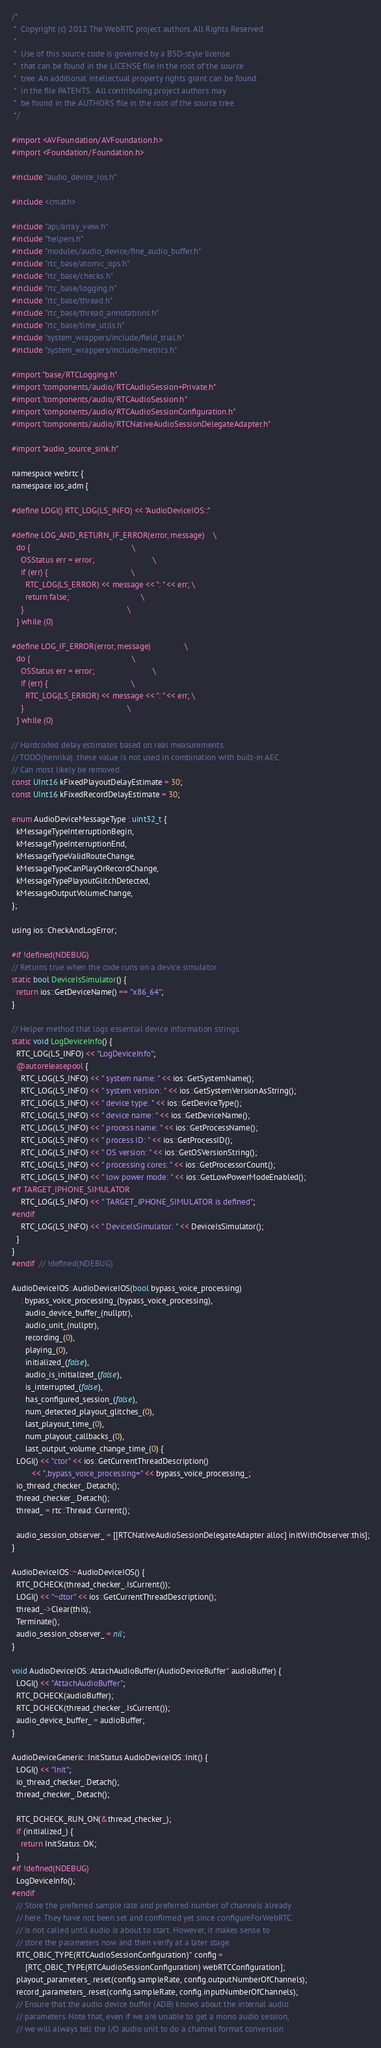Convert code to text. <code><loc_0><loc_0><loc_500><loc_500><_ObjectiveC_>/*
 *  Copyright (c) 2012 The WebRTC project authors. All Rights Reserved.
 *
 *  Use of this source code is governed by a BSD-style license
 *  that can be found in the LICENSE file in the root of the source
 *  tree. An additional intellectual property rights grant can be found
 *  in the file PATENTS.  All contributing project authors may
 *  be found in the AUTHORS file in the root of the source tree.
 */

#import <AVFoundation/AVFoundation.h>
#import <Foundation/Foundation.h>

#include "audio_device_ios.h"

#include <cmath>

#include "api/array_view.h"
#include "helpers.h"
#include "modules/audio_device/fine_audio_buffer.h"
#include "rtc_base/atomic_ops.h"
#include "rtc_base/checks.h"
#include "rtc_base/logging.h"
#include "rtc_base/thread.h"
#include "rtc_base/thread_annotations.h"
#include "rtc_base/time_utils.h"
#include "system_wrappers/include/field_trial.h"
#include "system_wrappers/include/metrics.h"

#import "base/RTCLogging.h"
#import "components/audio/RTCAudioSession+Private.h"
#import "components/audio/RTCAudioSession.h"
#import "components/audio/RTCAudioSessionConfiguration.h"
#import "components/audio/RTCNativeAudioSessionDelegateAdapter.h"

#import "audio_source_sink.h"

namespace webrtc {
namespace ios_adm {

#define LOGI() RTC_LOG(LS_INFO) << "AudioDeviceIOS::"

#define LOG_AND_RETURN_IF_ERROR(error, message)    \
  do {                                             \
    OSStatus err = error;                          \
    if (err) {                                     \
      RTC_LOG(LS_ERROR) << message << ": " << err; \
      return false;                                \
    }                                              \
  } while (0)

#define LOG_IF_ERROR(error, message)               \
  do {                                             \
    OSStatus err = error;                          \
    if (err) {                                     \
      RTC_LOG(LS_ERROR) << message << ": " << err; \
    }                                              \
  } while (0)

// Hardcoded delay estimates based on real measurements.
// TODO(henrika): these value is not used in combination with built-in AEC.
// Can most likely be removed.
const UInt16 kFixedPlayoutDelayEstimate = 30;
const UInt16 kFixedRecordDelayEstimate = 30;

enum AudioDeviceMessageType : uint32_t {
  kMessageTypeInterruptionBegin,
  kMessageTypeInterruptionEnd,
  kMessageTypeValidRouteChange,
  kMessageTypeCanPlayOrRecordChange,
  kMessageTypePlayoutGlitchDetected,
  kMessageOutputVolumeChange,
};

using ios::CheckAndLogError;

#if !defined(NDEBUG)
// Returns true when the code runs on a device simulator.
static bool DeviceIsSimulator() {
  return ios::GetDeviceName() == "x86_64";
}

// Helper method that logs essential device information strings.
static void LogDeviceInfo() {
  RTC_LOG(LS_INFO) << "LogDeviceInfo";
  @autoreleasepool {
    RTC_LOG(LS_INFO) << " system name: " << ios::GetSystemName();
    RTC_LOG(LS_INFO) << " system version: " << ios::GetSystemVersionAsString();
    RTC_LOG(LS_INFO) << " device type: " << ios::GetDeviceType();
    RTC_LOG(LS_INFO) << " device name: " << ios::GetDeviceName();
    RTC_LOG(LS_INFO) << " process name: " << ios::GetProcessName();
    RTC_LOG(LS_INFO) << " process ID: " << ios::GetProcessID();
    RTC_LOG(LS_INFO) << " OS version: " << ios::GetOSVersionString();
    RTC_LOG(LS_INFO) << " processing cores: " << ios::GetProcessorCount();
    RTC_LOG(LS_INFO) << " low power mode: " << ios::GetLowPowerModeEnabled();
#if TARGET_IPHONE_SIMULATOR
    RTC_LOG(LS_INFO) << " TARGET_IPHONE_SIMULATOR is defined";
#endif
    RTC_LOG(LS_INFO) << " DeviceIsSimulator: " << DeviceIsSimulator();
  }
}
#endif  // !defined(NDEBUG)

AudioDeviceIOS::AudioDeviceIOS(bool bypass_voice_processing)
    : bypass_voice_processing_(bypass_voice_processing),
      audio_device_buffer_(nullptr),
      audio_unit_(nullptr),
      recording_(0),
      playing_(0),
      initialized_(false),
      audio_is_initialized_(false),
      is_interrupted_(false),
      has_configured_session_(false),
      num_detected_playout_glitches_(0),
      last_playout_time_(0),
      num_playout_callbacks_(0),
      last_output_volume_change_time_(0) {
  LOGI() << "ctor" << ios::GetCurrentThreadDescription()
         << ",bypass_voice_processing=" << bypass_voice_processing_;
  io_thread_checker_.Detach();
  thread_checker_.Detach();
  thread_ = rtc::Thread::Current();

  audio_session_observer_ = [[RTCNativeAudioSessionDelegateAdapter alloc] initWithObserver:this];
}

AudioDeviceIOS::~AudioDeviceIOS() {
  RTC_DCHECK(thread_checker_.IsCurrent());
  LOGI() << "~dtor" << ios::GetCurrentThreadDescription();
  thread_->Clear(this);
  Terminate();
  audio_session_observer_ = nil;
}

void AudioDeviceIOS::AttachAudioBuffer(AudioDeviceBuffer* audioBuffer) {
  LOGI() << "AttachAudioBuffer";
  RTC_DCHECK(audioBuffer);
  RTC_DCHECK(thread_checker_.IsCurrent());
  audio_device_buffer_ = audioBuffer;
}

AudioDeviceGeneric::InitStatus AudioDeviceIOS::Init() {
  LOGI() << "Init";
  io_thread_checker_.Detach();
  thread_checker_.Detach();

  RTC_DCHECK_RUN_ON(&thread_checker_);
  if (initialized_) {
    return InitStatus::OK;
  }
#if !defined(NDEBUG)
  LogDeviceInfo();
#endif
  // Store the preferred sample rate and preferred number of channels already
  // here. They have not been set and confirmed yet since configureForWebRTC
  // is not called until audio is about to start. However, it makes sense to
  // store the parameters now and then verify at a later stage.
  RTC_OBJC_TYPE(RTCAudioSessionConfiguration)* config =
      [RTC_OBJC_TYPE(RTCAudioSessionConfiguration) webRTCConfiguration];
  playout_parameters_.reset(config.sampleRate, config.outputNumberOfChannels);
  record_parameters_.reset(config.sampleRate, config.inputNumberOfChannels);
  // Ensure that the audio device buffer (ADB) knows about the internal audio
  // parameters. Note that, even if we are unable to get a mono audio session,
  // we will always tell the I/O audio unit to do a channel format conversion</code> 